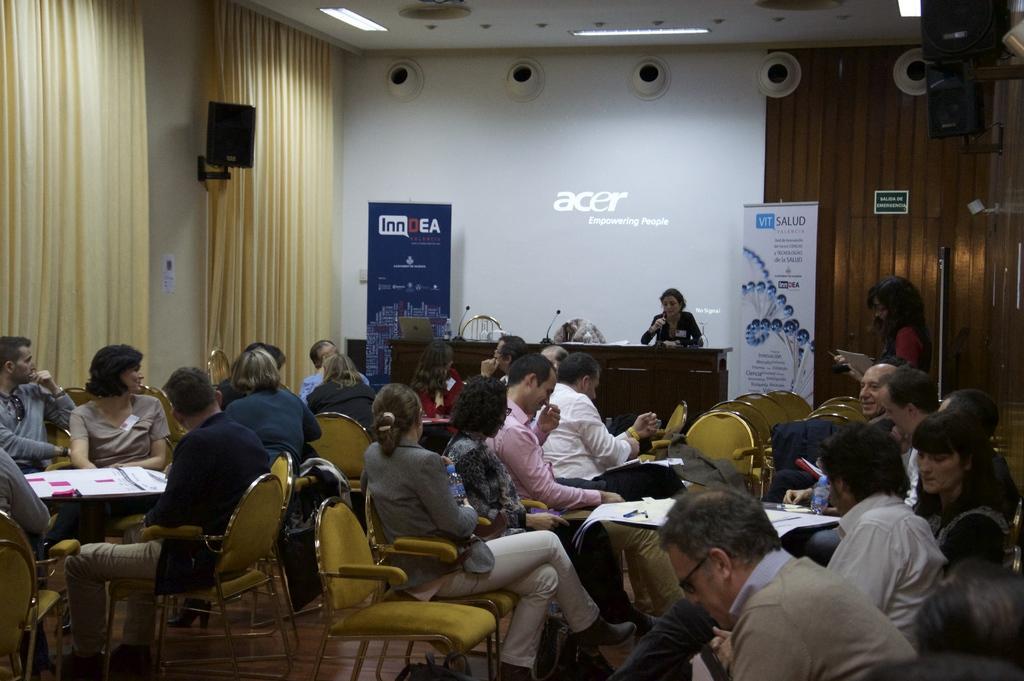Could you give a brief overview of what you see in this image? In this picture there are many people sitting on yellow chairs and in the background we observe a lady sitting on a brown table and talking with a mic in her hand. In the background there is a screen on which acer is written , empowering people. There are posterior to the both the sides of the image. In the background there are A holes and white lights fitted to the roof. 